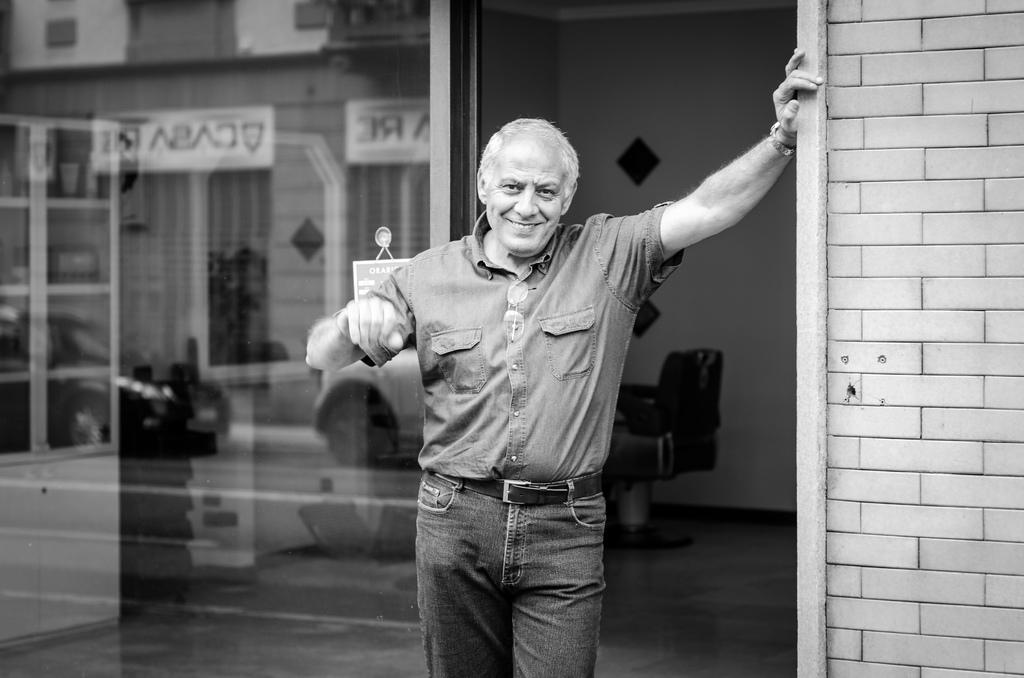What is the main subject of the image? There is a person standing in the image. What is the person doing in the image? The person has their hands on a brick wall. What can be seen in the background of the image? There is a chair, a glass door, and a wall in the background of the image. What is the profit margin of the page in the image? There is no page or profit margin mentioned in the image; it features a person standing with their hands on a brick wall and a background with a chair, a glass door, and a wall. 